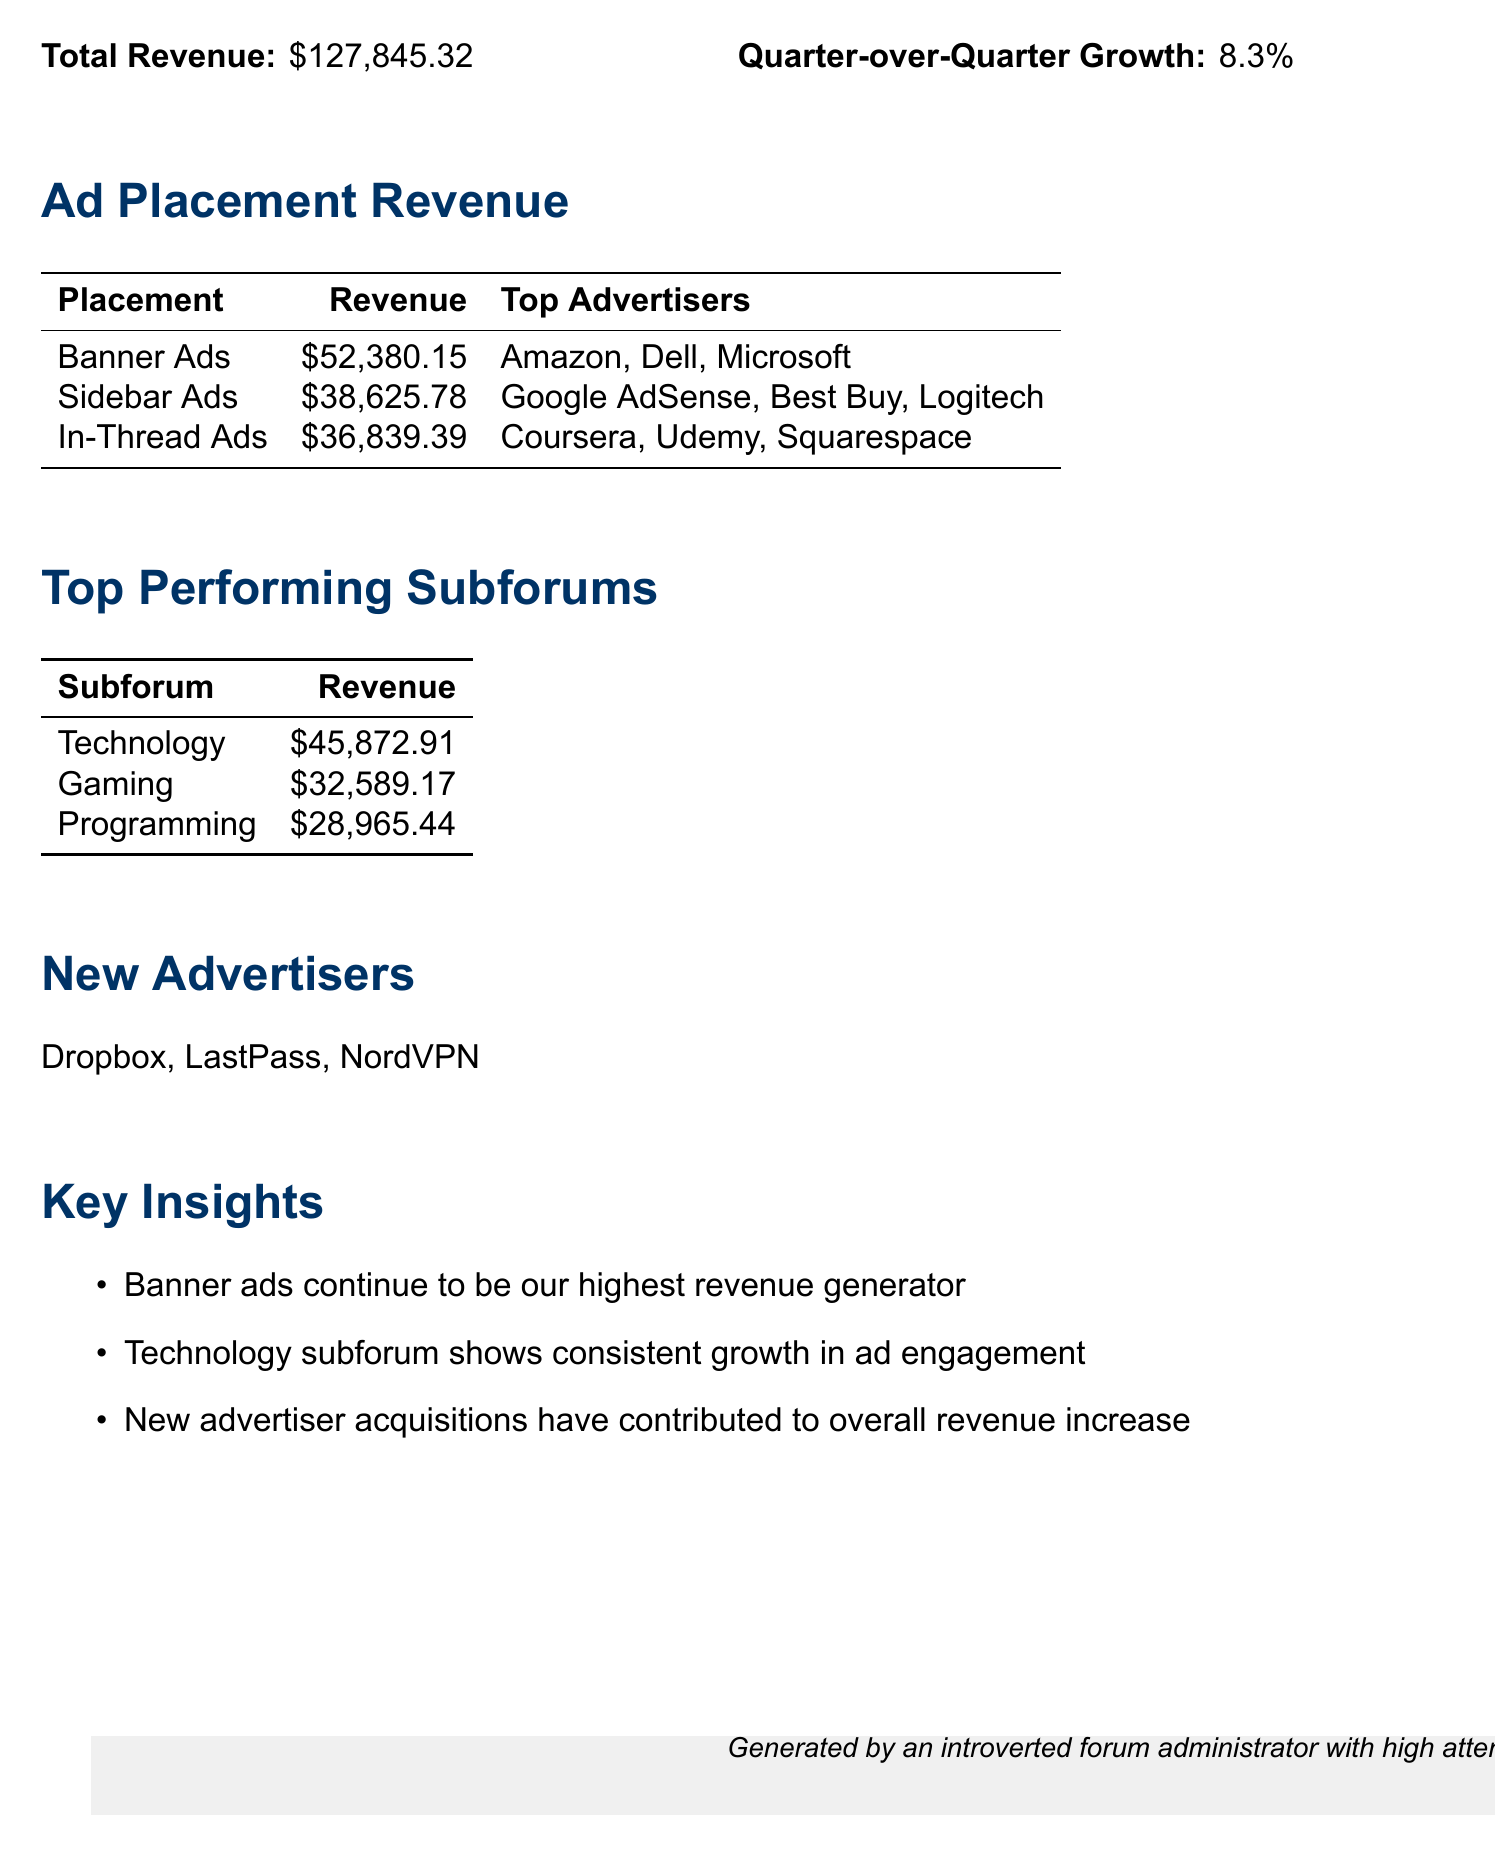What is the total revenue? The total revenue is clearly stated at the top of the document as $127,845.32.
Answer: $127,845.32 What percentage is the quarter-over-quarter growth? The document specifies the growth percentage, listed as 8.3%.
Answer: 8.3% Which ad placement generated the highest revenue? By looking at the ad placement revenue section, the highest revenue generator is identified as the "Banner Ads" with $52,380.15.
Answer: Banner Ads Who are the top advertisers for Sidebar Ads? The document lists the top advertisers associated with Sidebar Ads, which are identified as Google AdSense, Best Buy, and Logitech.
Answer: Google AdSense, Best Buy, Logitech Which subforum generated the most revenue? The revenue table for top performing subforums indicates that "Technology" is the leading subforum with a revenue of $45,872.91.
Answer: Technology What are the names of the new advertisers? The section for new advertisers explicitly lists them as Dropbox, LastPass, and NordVPN.
Answer: Dropbox, LastPass, NordVPN How much revenue did In-Thread Ads generate? The document specifies that In-Thread Ads generated a revenue of $36,839.39.
Answer: $36,839.39 What insight highlights the performance of new advertisers? A key insight mentions that new advertiser acquisitions have contributed to the overall revenue increase, indicating their impact on earnings.
Answer: New advertiser acquisitions have contributed to overall revenue increase Which ad placement showed the second highest revenue? By comparing the revenue figures, Sidebar Ads is identified as the second highest revenue generator after Banner Ads, at $38,625.78.
Answer: Sidebar Ads 